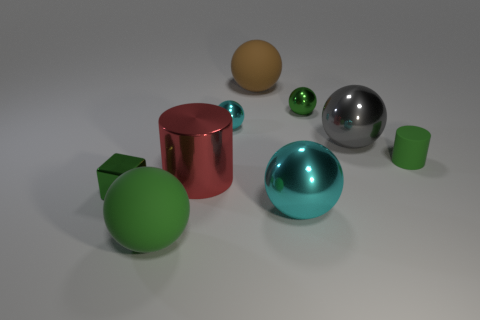Subtract 2 spheres. How many spheres are left? 4 Subtract all gray balls. How many balls are left? 5 Subtract all large cyan spheres. How many spheres are left? 5 Subtract all yellow balls. Subtract all blue cylinders. How many balls are left? 6 Subtract all cylinders. How many objects are left? 7 Subtract 0 cyan cylinders. How many objects are left? 9 Subtract all large blue cubes. Subtract all green metallic blocks. How many objects are left? 8 Add 1 shiny spheres. How many shiny spheres are left? 5 Add 2 green metal blocks. How many green metal blocks exist? 3 